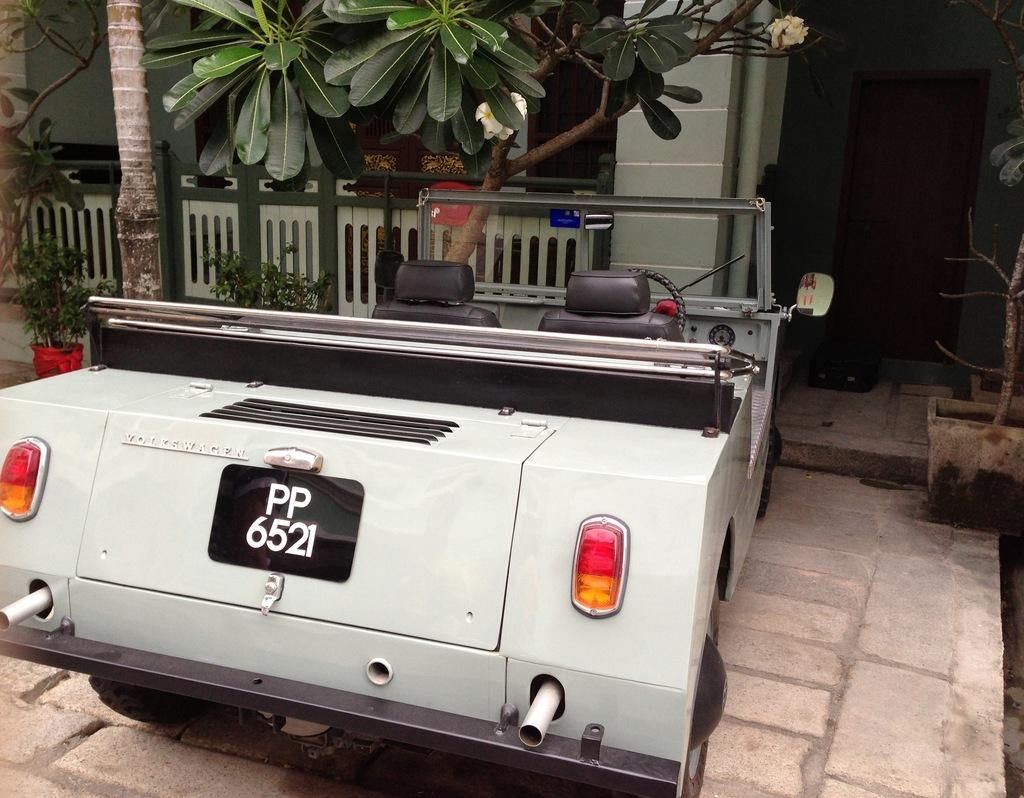What is the main subject in the image? There is a vehicle in the image. What can be seen beneath the vehicle? The ground is visible in the image. What type of vegetation is present in the image? There are trees and plants in a pot in the image. What architectural features can be seen in the image? There is a pillar and a wall in the image. What type of mark does the beginner make on the pencil in the image? There is no pencil or mark-making activity present in the image. 